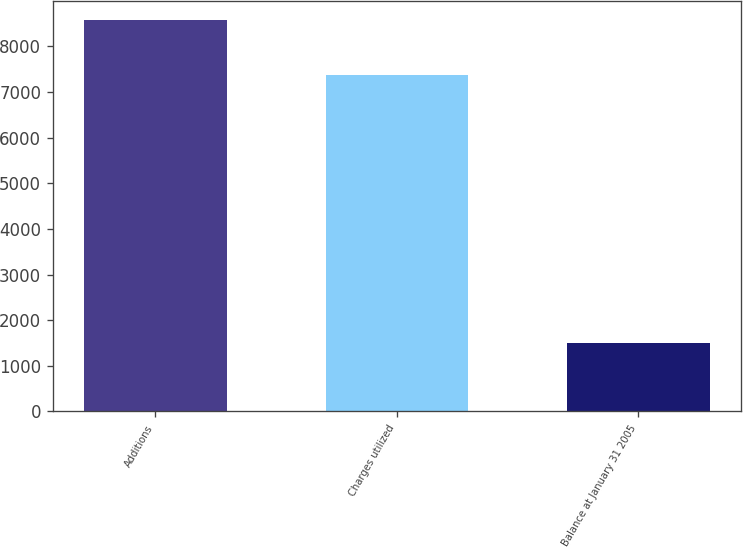Convert chart to OTSL. <chart><loc_0><loc_0><loc_500><loc_500><bar_chart><fcel>Additions<fcel>Charges utilized<fcel>Balance at January 31 2005<nl><fcel>8568<fcel>7365<fcel>1497<nl></chart> 